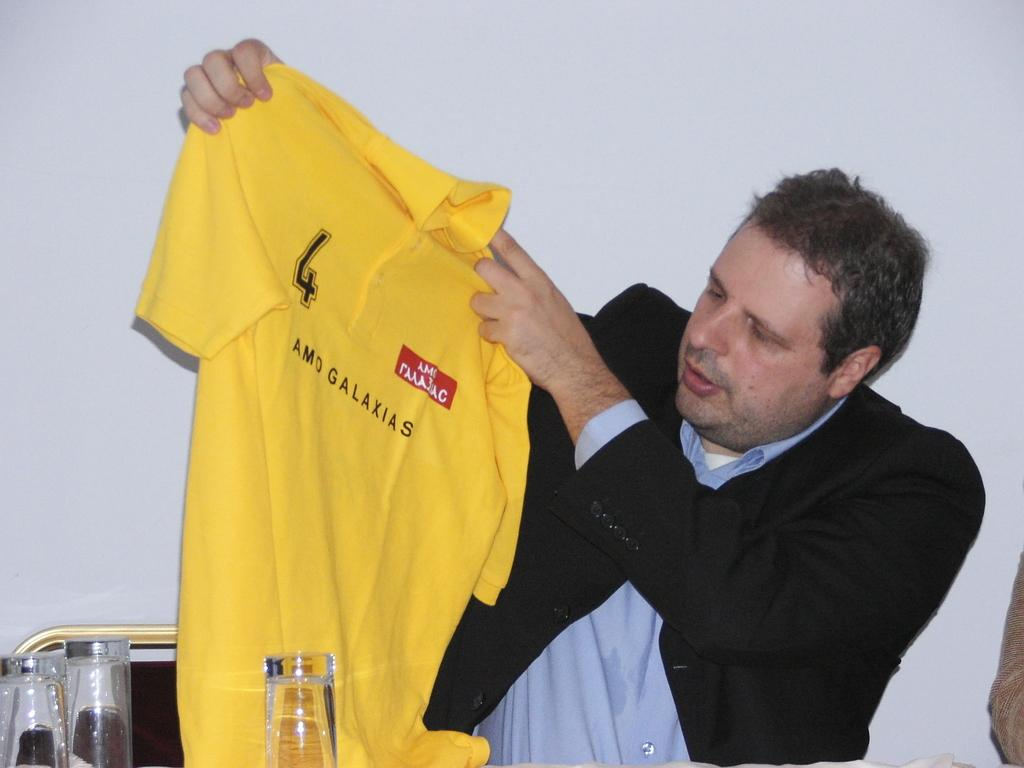<image>
Present a compact description of the photo's key features. A man holding up a yellow sports polo shirt with the name Amo on it. 